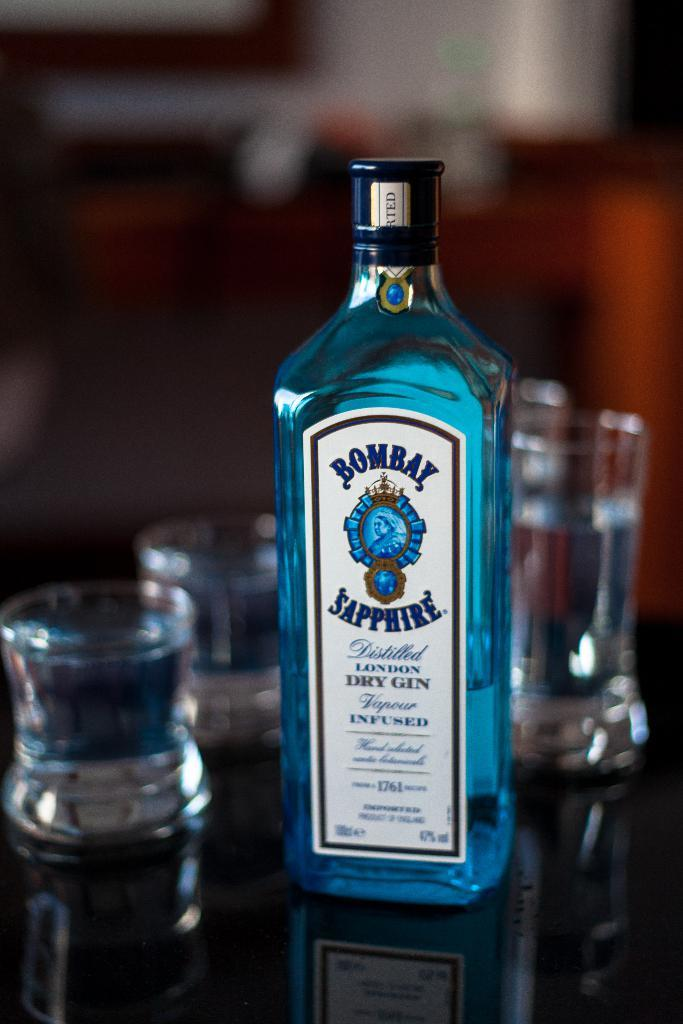<image>
Write a terse but informative summary of the picture. A bottle of Bombay Sapphire gin sits on a table with glasses 